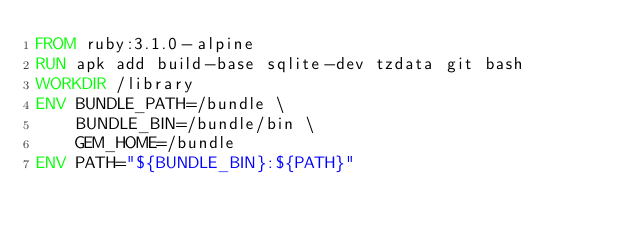Convert code to text. <code><loc_0><loc_0><loc_500><loc_500><_Dockerfile_>FROM ruby:3.1.0-alpine
RUN apk add build-base sqlite-dev tzdata git bash
WORKDIR /library
ENV BUNDLE_PATH=/bundle \
    BUNDLE_BIN=/bundle/bin \
    GEM_HOME=/bundle
ENV PATH="${BUNDLE_BIN}:${PATH}"
</code> 